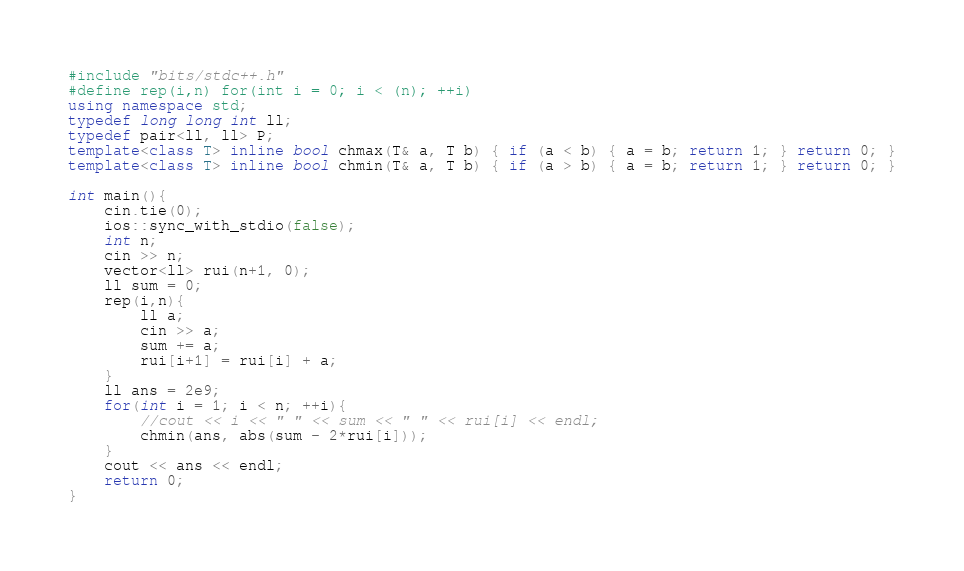Convert code to text. <code><loc_0><loc_0><loc_500><loc_500><_C++_>#include "bits/stdc++.h"
#define rep(i,n) for(int i = 0; i < (n); ++i)
using namespace std;
typedef long long int ll;
typedef pair<ll, ll> P;
template<class T> inline bool chmax(T& a, T b) { if (a < b) { a = b; return 1; } return 0; }
template<class T> inline bool chmin(T& a, T b) { if (a > b) { a = b; return 1; } return 0; }

int main(){
	cin.tie(0);
	ios::sync_with_stdio(false);
	int n;
	cin >> n;
	vector<ll> rui(n+1, 0);
	ll sum = 0;
	rep(i,n){
		ll a;
		cin >> a;
		sum += a;
		rui[i+1] = rui[i] + a;
	}
	ll ans = 2e9;
	for(int i = 1; i < n; ++i){
		//cout << i << " " << sum << " " << rui[i] << endl;
		chmin(ans, abs(sum - 2*rui[i]));
	}
	cout << ans << endl;
	return 0;
}</code> 